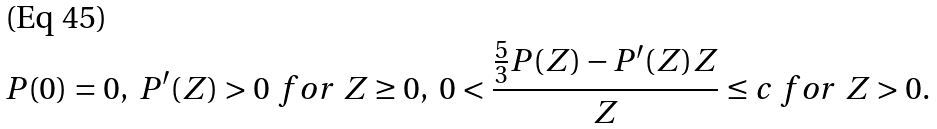Convert formula to latex. <formula><loc_0><loc_0><loc_500><loc_500>P ( 0 ) = 0 , \ P ^ { \prime } ( Z ) > 0 \ f o r \ Z \geq 0 , \ 0 < \frac { \frac { 5 } { 3 } P ( Z ) - P ^ { \prime } ( Z ) Z } { Z } \leq c \ f o r \ Z > 0 .</formula> 